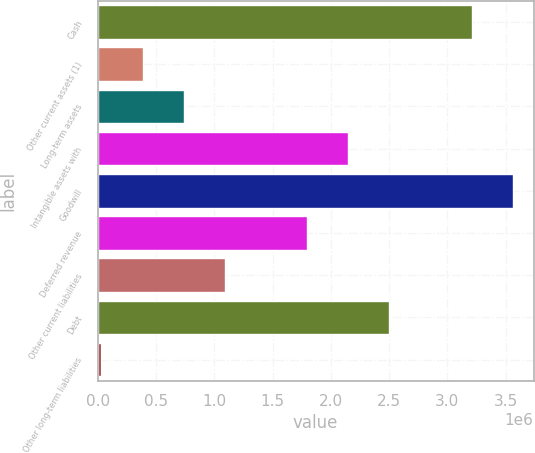<chart> <loc_0><loc_0><loc_500><loc_500><bar_chart><fcel>Cash<fcel>Other current assets (1)<fcel>Long-term assets<fcel>Intangible assets with<fcel>Goodwill<fcel>Deferred revenue<fcel>Other current liabilities<fcel>Debt<fcel>Other long-term liabilities<nl><fcel>3.20921e+06<fcel>384243<fcel>737363<fcel>2.14985e+06<fcel>3.56233e+06<fcel>1.79673e+06<fcel>1.09048e+06<fcel>2.50297e+06<fcel>31122<nl></chart> 